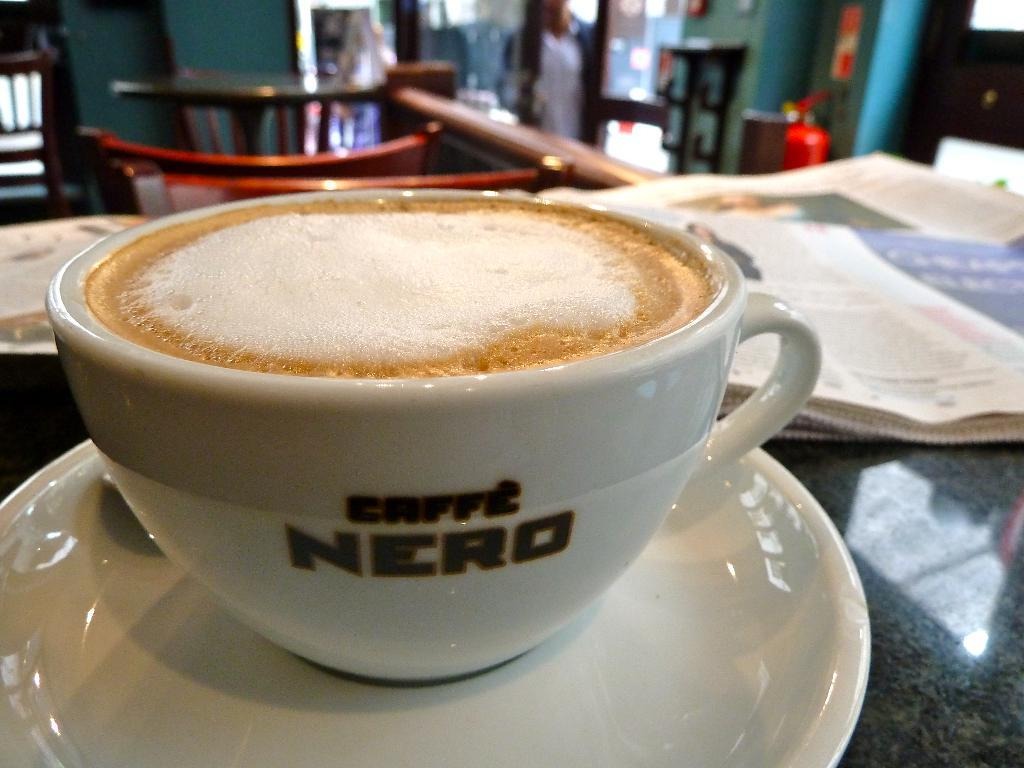What piece of furniture is in the image? There is a table in the image. What is on the table? A cup, a saucer, and papers are on the table. Are there any chairs in the image? Yes, there are chairs in the image. What can be seen in the background of the image? There is a person, a fire extinguisher, a wall, and a door in the background. Can you see a kitten playing with a rose on the table in the image? No, there is no kitten or rose present on the table in the image. 